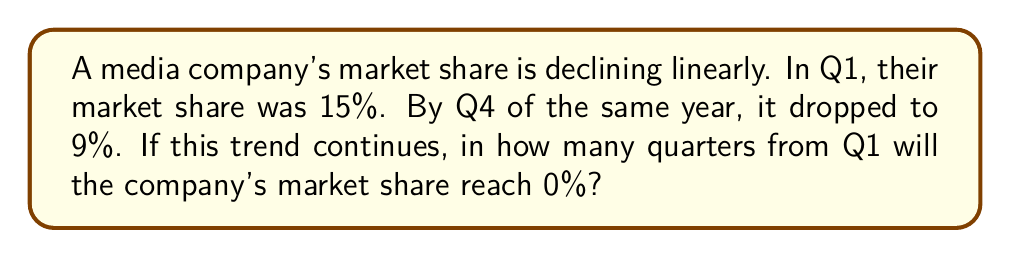Teach me how to tackle this problem. Let's approach this step-by-step:

1) First, we need to determine the rate of decline per quarter. We can set up a linear equation:

   $y = mx + b$

   Where $y$ is the market share, $m$ is the rate of decline, $x$ is the number of quarters, and $b$ is the initial market share.

2) We know two points:
   Q1 (x = 0): y = 15%
   Q4 (x = 3): y = 9%

3) We can substitute these into our equation:
   15 = m(0) + b
   9 = m(3) + b

4) From the first equation, we can see that $b = 15$

5) Substituting this into the second equation:
   9 = 3m + 15
   -6 = 3m
   m = -2

6) So our equation is:
   $y = -2x + 15$

7) To find when the market share reaches 0, we set y to 0:
   $0 = -2x + 15$
   $2x = 15$
   $x = 7.5$

8) Since x represents quarters, we need to round up to the next whole number.
Answer: 8 quarters 